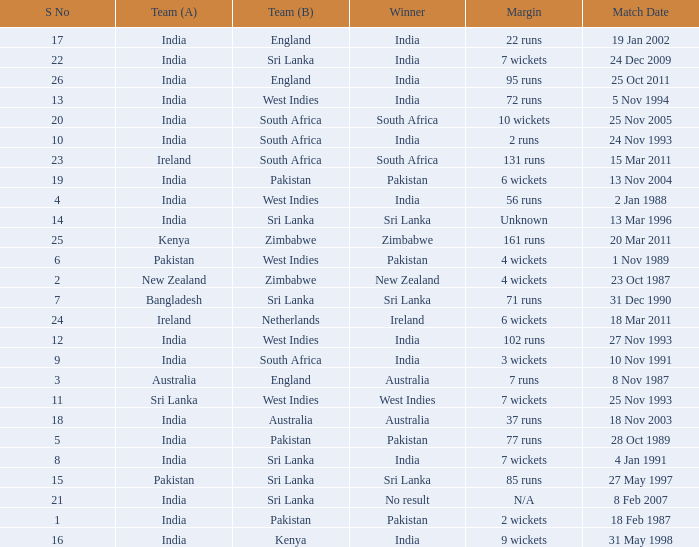Write the full table. {'header': ['S No', 'Team (A)', 'Team (B)', 'Winner', 'Margin', 'Match Date'], 'rows': [['17', 'India', 'England', 'India', '22 runs', '19 Jan 2002'], ['22', 'India', 'Sri Lanka', 'India', '7 wickets', '24 Dec 2009'], ['26', 'India', 'England', 'India', '95 runs', '25 Oct 2011'], ['13', 'India', 'West Indies', 'India', '72 runs', '5 Nov 1994'], ['20', 'India', 'South Africa', 'South Africa', '10 wickets', '25 Nov 2005'], ['10', 'India', 'South Africa', 'India', '2 runs', '24 Nov 1993'], ['23', 'Ireland', 'South Africa', 'South Africa', '131 runs', '15 Mar 2011'], ['19', 'India', 'Pakistan', 'Pakistan', '6 wickets', '13 Nov 2004'], ['4', 'India', 'West Indies', 'India', '56 runs', '2 Jan 1988'], ['14', 'India', 'Sri Lanka', 'Sri Lanka', 'Unknown', '13 Mar 1996'], ['25', 'Kenya', 'Zimbabwe', 'Zimbabwe', '161 runs', '20 Mar 2011'], ['6', 'Pakistan', 'West Indies', 'Pakistan', '4 wickets', '1 Nov 1989'], ['2', 'New Zealand', 'Zimbabwe', 'New Zealand', '4 wickets', '23 Oct 1987'], ['7', 'Bangladesh', 'Sri Lanka', 'Sri Lanka', '71 runs', '31 Dec 1990'], ['24', 'Ireland', 'Netherlands', 'Ireland', '6 wickets', '18 Mar 2011'], ['12', 'India', 'West Indies', 'India', '102 runs', '27 Nov 1993'], ['9', 'India', 'South Africa', 'India', '3 wickets', '10 Nov 1991'], ['3', 'Australia', 'England', 'Australia', '7 runs', '8 Nov 1987'], ['11', 'Sri Lanka', 'West Indies', 'West Indies', '7 wickets', '25 Nov 1993'], ['18', 'India', 'Australia', 'Australia', '37 runs', '18 Nov 2003'], ['5', 'India', 'Pakistan', 'Pakistan', '77 runs', '28 Oct 1989'], ['8', 'India', 'Sri Lanka', 'India', '7 wickets', '4 Jan 1991'], ['15', 'Pakistan', 'Sri Lanka', 'Sri Lanka', '85 runs', '27 May 1997'], ['21', 'India', 'Sri Lanka', 'No result', 'N/A', '8 Feb 2007'], ['1', 'India', 'Pakistan', 'Pakistan', '2 wickets', '18 Feb 1987'], ['16', 'India', 'Kenya', 'India', '9 wickets', '31 May 1998']]} What date did the West Indies win the match? 25 Nov 1993. 